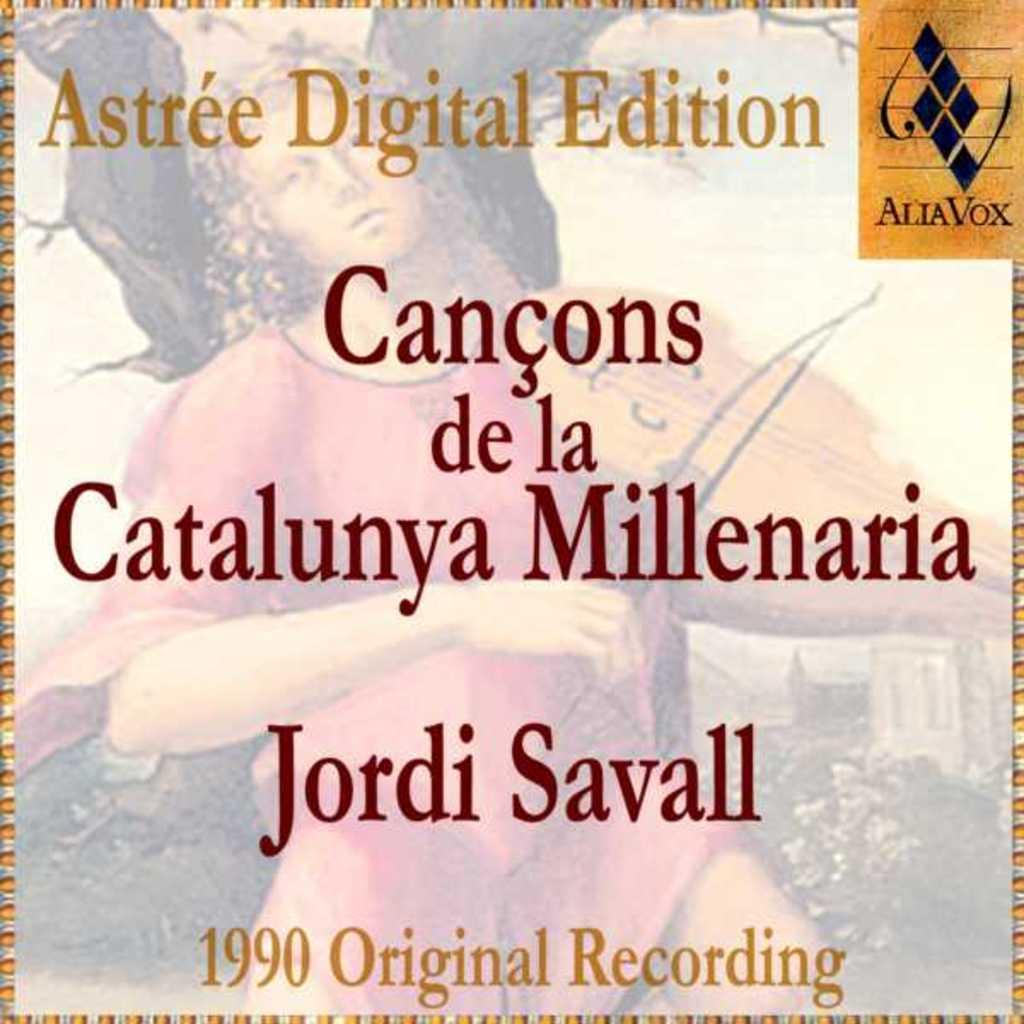<image>
Write a terse but informative summary of the picture. Cover which says the words 'Astree Digital Edition" on top. 